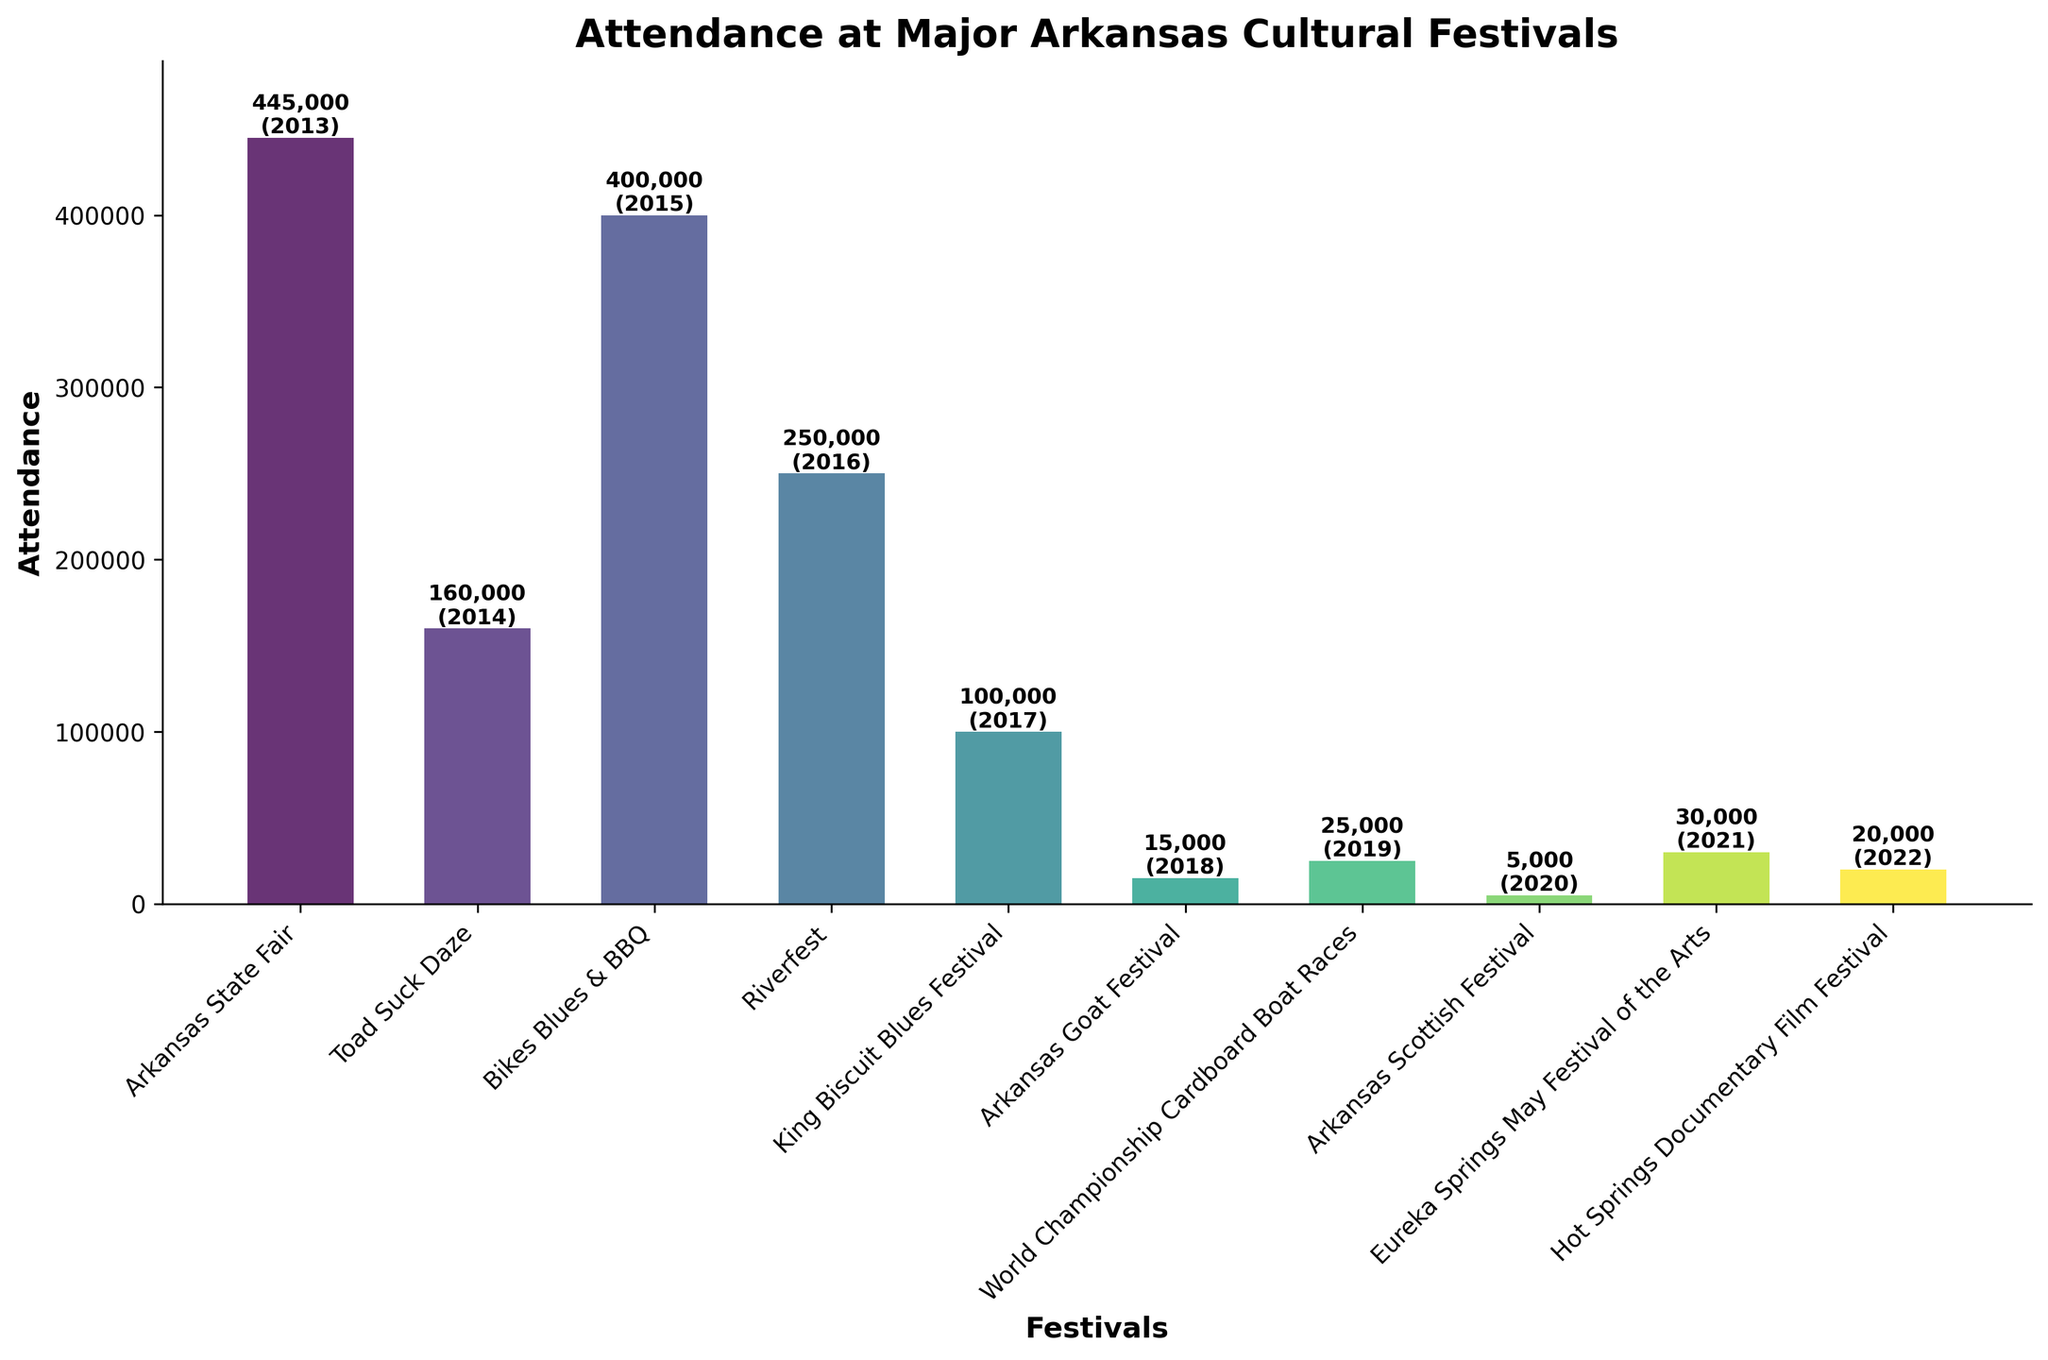What's the total attendance for the festivals from 2019 to 2022? Sum the attendance numbers for the festivals in 2019 (25,000), 2020 (5,000), 2021 (30,000), and 2022 (20,000). The total attendance is 25,000 + 5,000 + 30,000 + 20,000 = 80,000
Answer: 80,000 Which festival had the highest attendance and what was the attendance figure? Look at the heights of the bars. The tallest bar corresponds to "Arkansas State Fair" with an attendance of 445,000
Answer: Arkansas State Fair, 445,000 How does the attendance at Toad Suck Daze compare to the Arkansas Goat Festival? Compare the heights of Toad Suck Daze (160,000) and Arkansas Goat Festival (15,000). Toad Suck Daze has a higher attendance than Arkansas Goat Festival.
Answer: Toad Suck Daze has higher attendance What's the average attendance for the festivals with attendance figures above 100,000? Identify festivals above 100,000 attendance: Arkansas State Fair (445,000), Toad Suck Daze (160,000), Bikes Blues & BBQ (400,000), Riverfest (250,000). Average = (445,000 + 160,000 + 400,000 + 250,000) / 4 = 312,500
Answer: 312,500 Which festival had the lowest attendance and what was the figure? Look for the shortest bar. The shortest bar corresponds to "Arkansas Scottish Festival" with an attendance of 5,000
Answer: Arkansas Scottish Festival, 5,000 How many festivals had an attendance figure between 10,000 and 50,000? Identify bars within the 10,000-50,000 range: Arkansas Goat Festival (15,000), World Championship Cardboard Boat Races (25,000), Eureka Springs May Festival of the Arts (30,000), Hot Springs Documentary Film Festival (20,000). There are 4 festivals in this range
Answer: 4 What's the difference in attendance between Bikes Blues & BBQ and King Biscuit Blues Festival? Subtract the attendance figures: Bikes Blues & BBQ (400,000) - King Biscuit Blues Festival (100,000). Difference is 400,000 - 100,000 = 300,000
Answer: 300,000 What's the median attendance figure of all the festivals? Arrange the attendance figures in ascending order: 5,000, 15,000, 20,000, 25,000, 30,000, 100,000, 150,000, 160,000, 250,000, 400,000, 445,000. The middle value is the sixth value: 100,000
Answer: 100,000 Which festival had the highest attendance in the last three years shown? Identify festivals and attendance from last three years: Eureka Springs May Festival of the Arts 2021 (30,000), Hot Springs Documentary Film Festival 2022 (20,000), World Championship Cardboard Boat Races 2019 (25,000). The highest is Eureka Springs May Festival of the Arts with 30,000
Answer: Eureka Springs May Festival of the Arts 2021, 30,000 